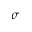<formula> <loc_0><loc_0><loc_500><loc_500>\sigma</formula> 